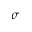<formula> <loc_0><loc_0><loc_500><loc_500>\sigma</formula> 